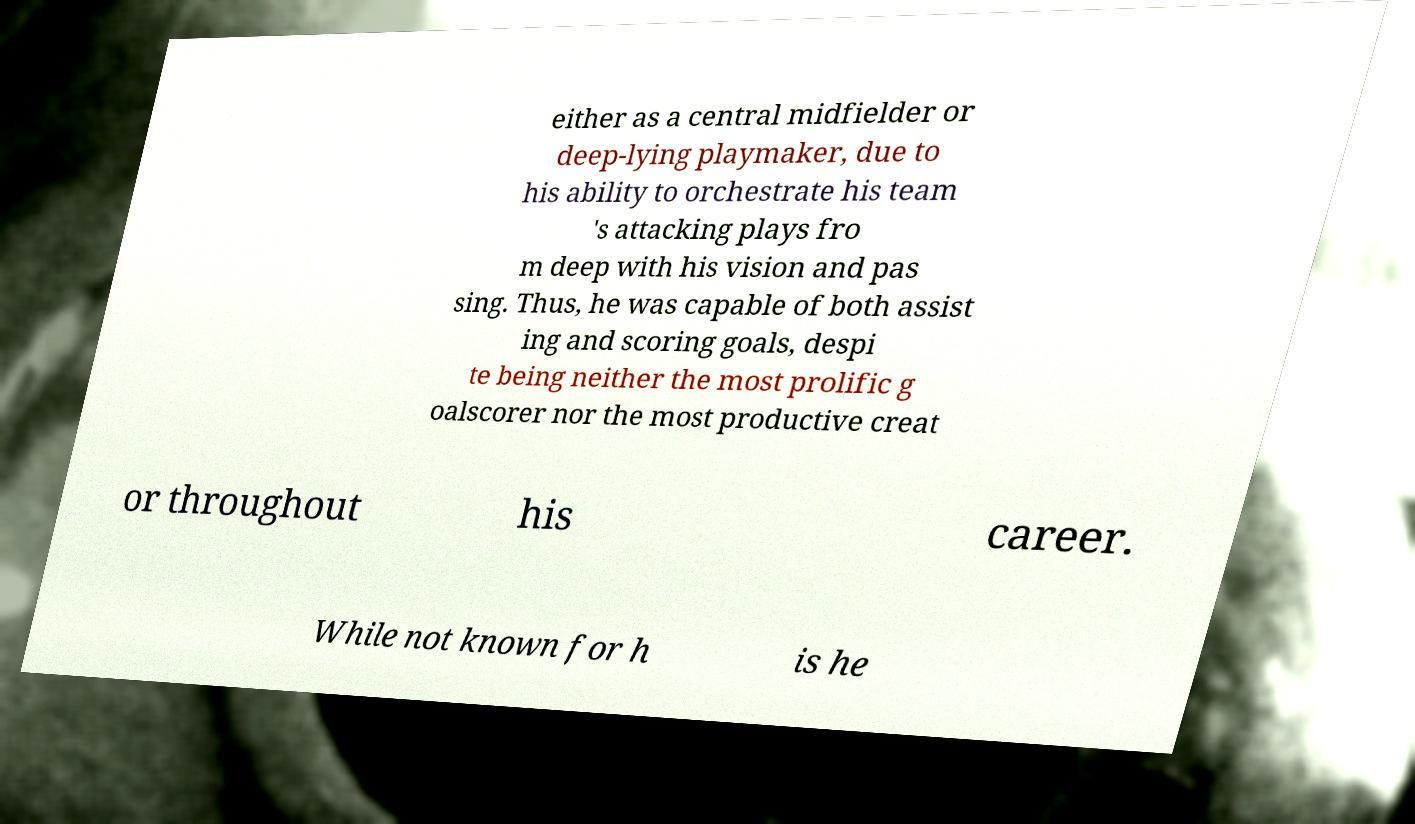For documentation purposes, I need the text within this image transcribed. Could you provide that? either as a central midfielder or deep-lying playmaker, due to his ability to orchestrate his team 's attacking plays fro m deep with his vision and pas sing. Thus, he was capable of both assist ing and scoring goals, despi te being neither the most prolific g oalscorer nor the most productive creat or throughout his career. While not known for h is he 